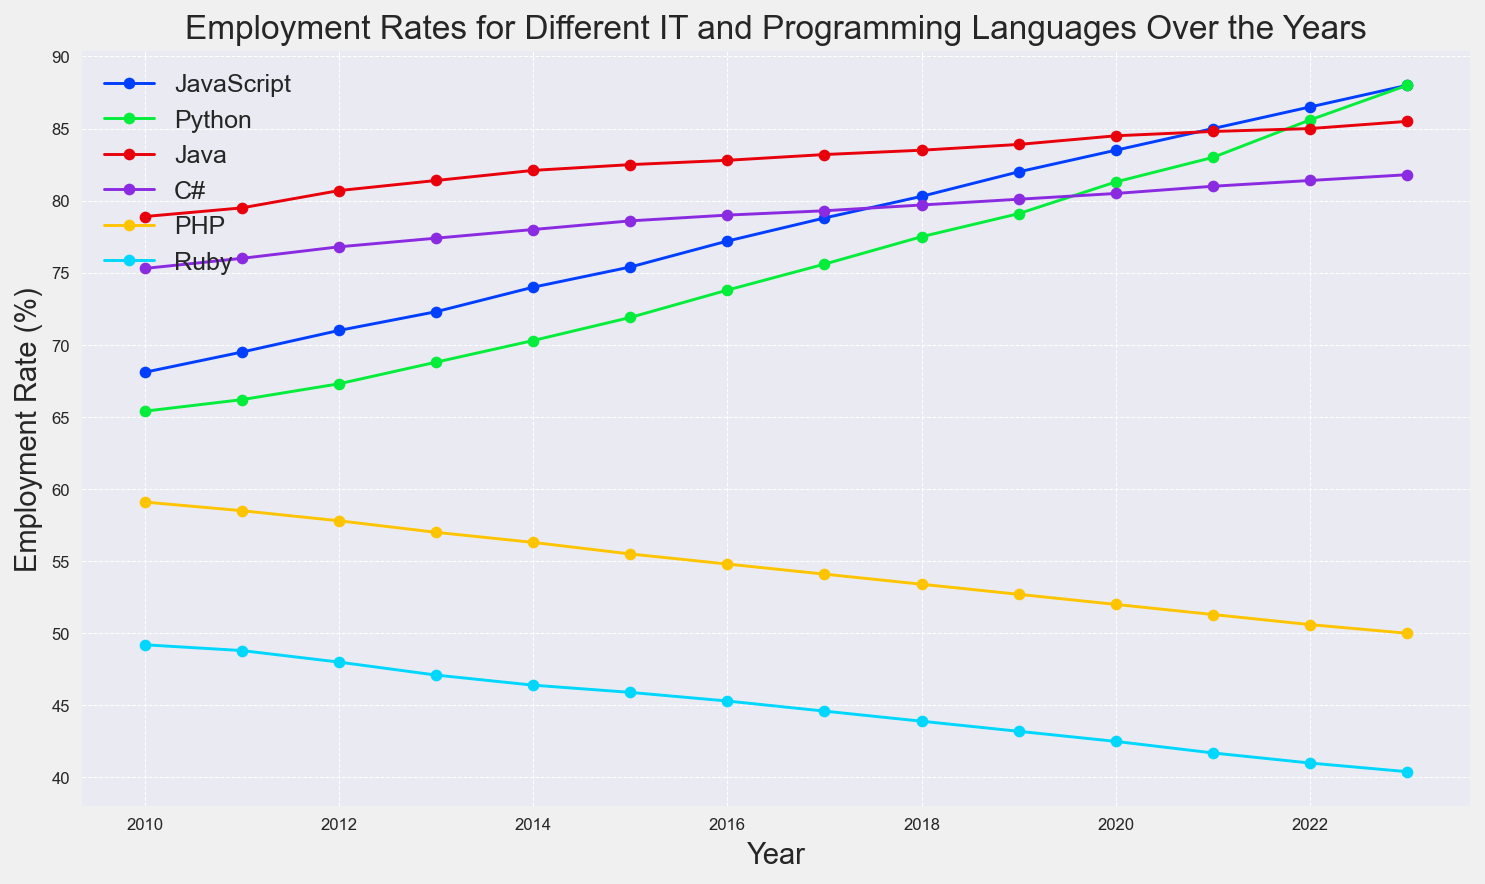What is the trend in employment rates for JavaScript from 2010 to 2023? To determine the trend in JavaScript employment rates, observe the line representing JavaScript from the figure. The line shows a continuous increase from 68.1% in 2010 to 88.0% in 2023.
Answer: Increasing Which programming language had the highest employment rate in 2023? To find the programming language with the highest employment rate in 2023, look at the endpoints of each line on the right side of the figure. JavaScript and Python both have the highest employment rates at 88.0%.
Answer: JavaScript and Python Between 2015 and 2020, which programming language experienced the highest growth in employment rates? Calculate the differences in employment rates for each language from 2015 to 2020. JavaScript: 83.5-75.4=8.1, Python: 81.3-71.9=9.4, Java: 84.5-82.5=2.0, C#: 80.5-78.6=1.9, PHP: 52.0-55.5=(-3.5), Ruby: 42.5-45.9=(-3.4). Python experienced the highest growth of 9.4%.
Answer: Python In which year did Python's employment rate surpass Java's employment rate? Compare the lines for Python and Java. Python's employment rate surpassed Java's in 2023, where Python has 88.0% and Java has 85.5%.
Answer: 2023 During which years did C# maintain an employment rate above 80%? Observe the line for C# and identify the years with employment rates above 80%. From the figure, C# maintained above 80% from 2019 to 2023.
Answer: 2019 to 2023 How does the employment rate of Ruby in 2023 compare to its rate in 2010? Note Ruby's employment rates in 2010 and 2023. Ruby's rate was 49.2% in 2010 and dropped to 40.4% in 2023.
Answer: Decreased What was the average employment rate for PHP between 2010 and 2023? Calculate the average of PHP employment rates from 2010 to 2023: (59.1 + 58.5 + 57.8 + 57.0 + 56.3 + 55.5 + 54.8 + 54.1 + 53.4 + 52.7 + 52.0 + 51.3 + 50.6 + 50.0) / 14. Summing these gives 763.1, so the average is 763.1/14 ≈ 54.5%.
Answer: 54.5% 